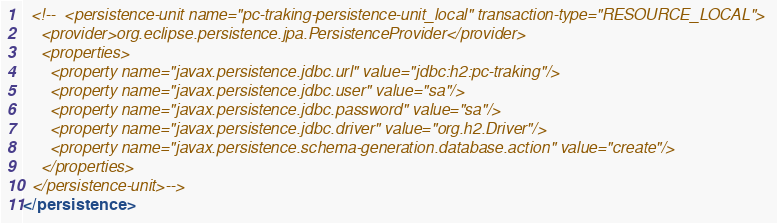Convert code to text. <code><loc_0><loc_0><loc_500><loc_500><_XML_>  <!--  <persistence-unit name="pc-traking-persistence-unit_local" transaction-type="RESOURCE_LOCAL">
    <provider>org.eclipse.persistence.jpa.PersistenceProvider</provider>
    <properties>
      <property name="javax.persistence.jdbc.url" value="jdbc:h2:pc-traking"/>
      <property name="javax.persistence.jdbc.user" value="sa"/>
      <property name="javax.persistence.jdbc.password" value="sa"/>
      <property name="javax.persistence.jdbc.driver" value="org.h2.Driver"/>
      <property name="javax.persistence.schema-generation.database.action" value="create"/>
    </properties>
  </persistence-unit>-->
</persistence>
</code> 